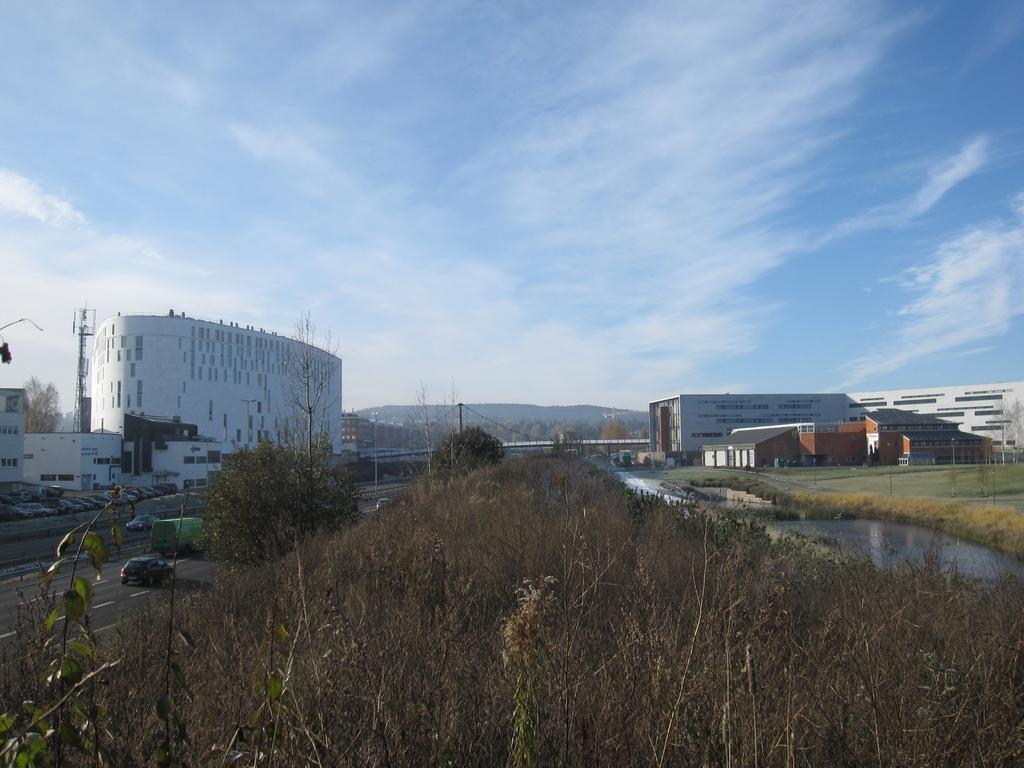What type of structures can be seen in the image? There are houses in the image. What else is visible in the image besides the houses? There are wires and trees visible in the image. Are there any vehicles present in the image? Yes, there are cars on the road in the image. How many snails can be seen crawling on the roofs of the houses in the image? There are no snails visible on the roofs of the houses in the image. What type of birds are perched on the wires in the image? There are no birds present on the wires in the image. 